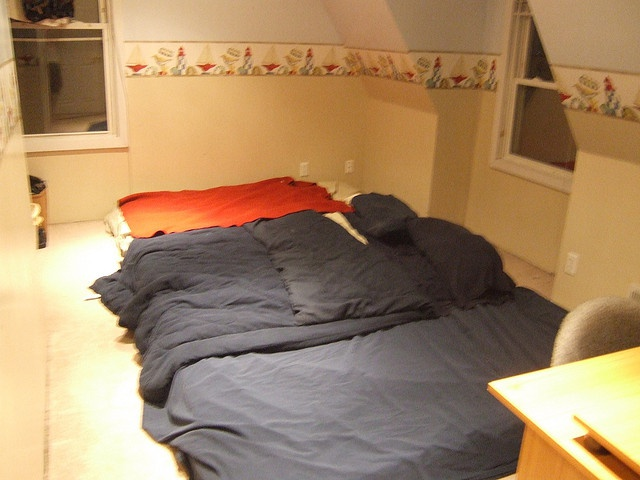Describe the objects in this image and their specific colors. I can see bed in tan, gray, and black tones, dining table in tan, lightyellow, khaki, and orange tones, and chair in tan, maroon, and gray tones in this image. 